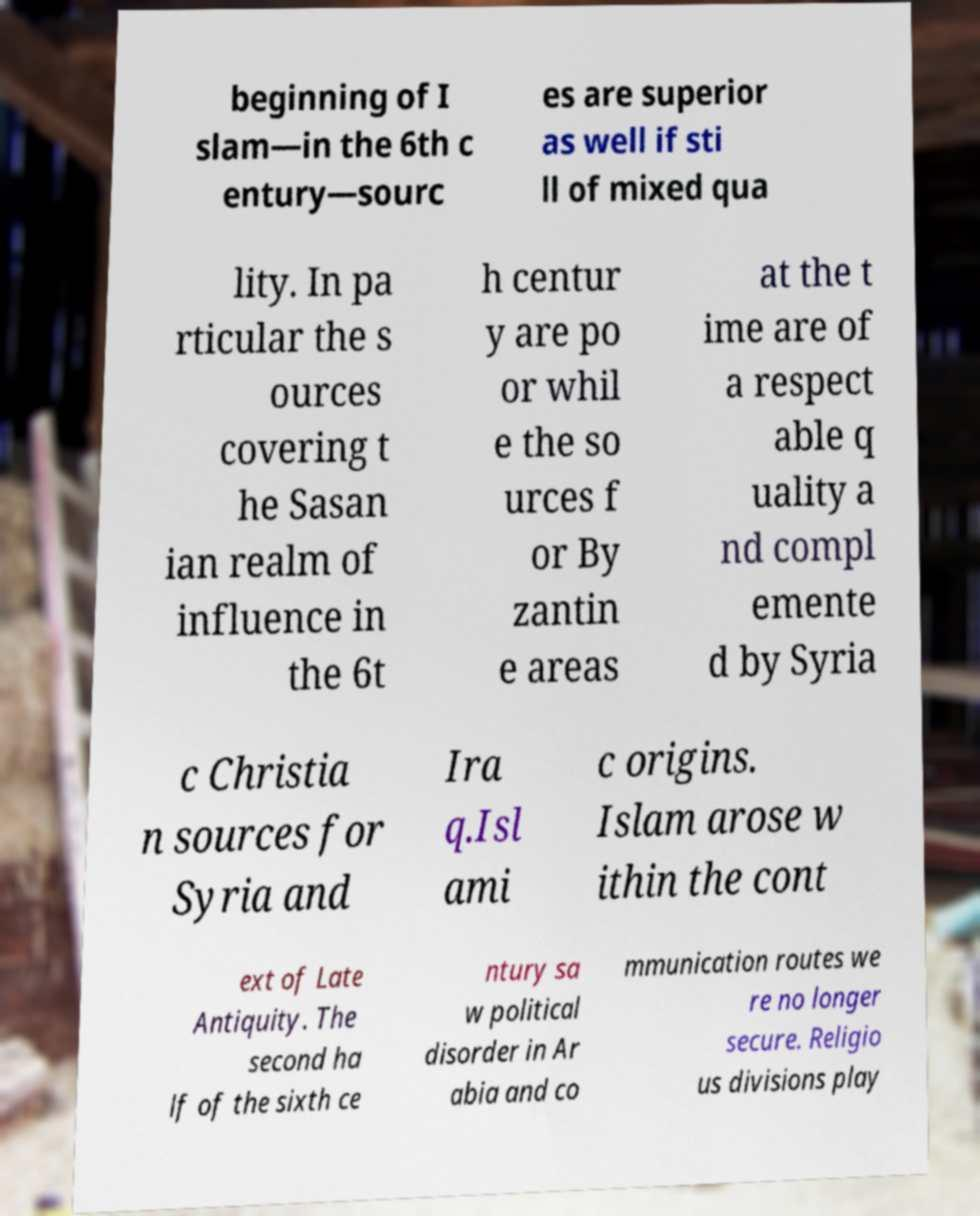Can you accurately transcribe the text from the provided image for me? beginning of I slam—in the 6th c entury—sourc es are superior as well if sti ll of mixed qua lity. In pa rticular the s ources covering t he Sasan ian realm of influence in the 6t h centur y are po or whil e the so urces f or By zantin e areas at the t ime are of a respect able q uality a nd compl emente d by Syria c Christia n sources for Syria and Ira q.Isl ami c origins. Islam arose w ithin the cont ext of Late Antiquity. The second ha lf of the sixth ce ntury sa w political disorder in Ar abia and co mmunication routes we re no longer secure. Religio us divisions play 